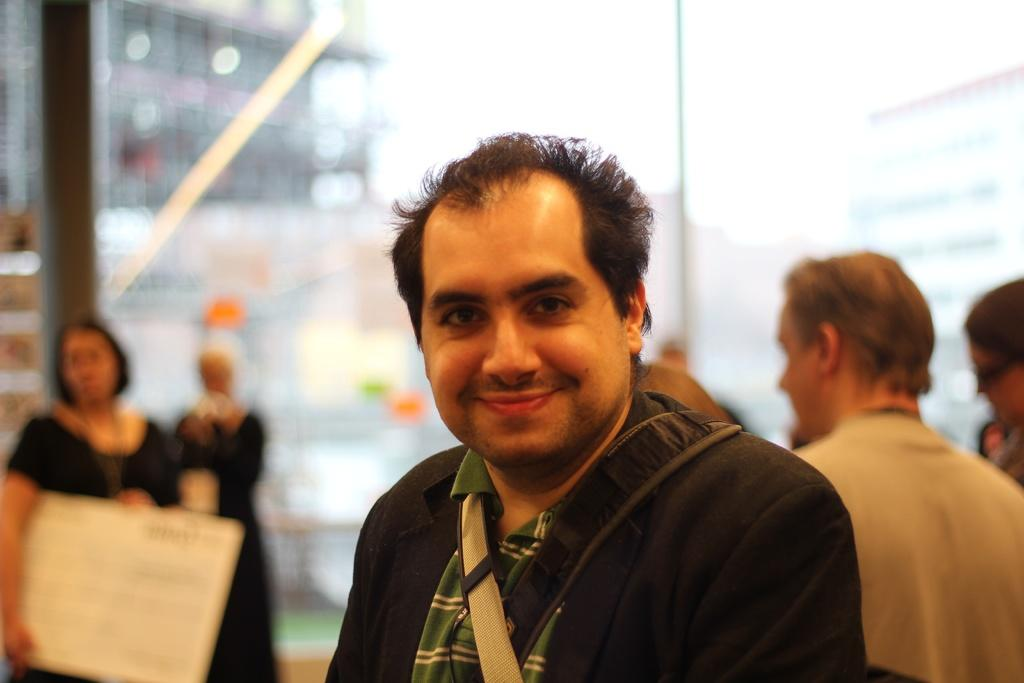Who is present in the image? There are people in the image. Can you describe the expression of one of the individuals? There is a man smiling in the image. How would you describe the background of the image? The background of the image is blurry. What type of spark can be seen in the office depicted in the image? There is no mention of an office or a spark in the image, so it cannot be determined from the provided facts. 